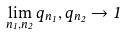Convert formula to latex. <formula><loc_0><loc_0><loc_500><loc_500>\lim _ { n _ { 1 } , n _ { 2 } } q _ { n _ { 1 } } , q _ { n _ { 2 } } \to 1</formula> 